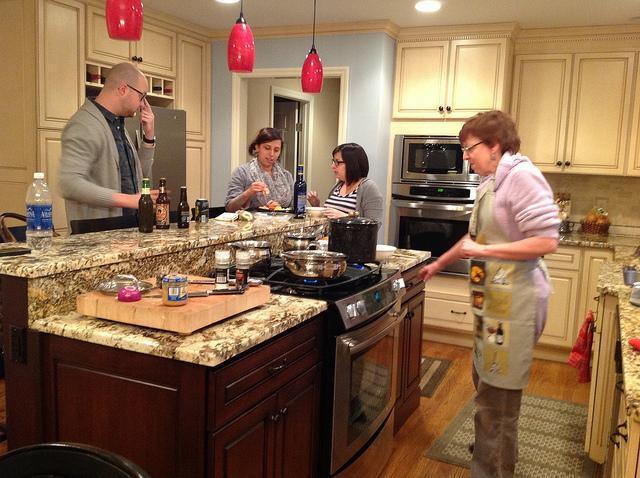What type of energy is being used by the stove?
Select the accurate answer and provide explanation: 'Answer: answer
Rationale: rationale.'
Options: Convection, microwave, gas, electric. Answer: gas.
Rationale: Gas is being used. 